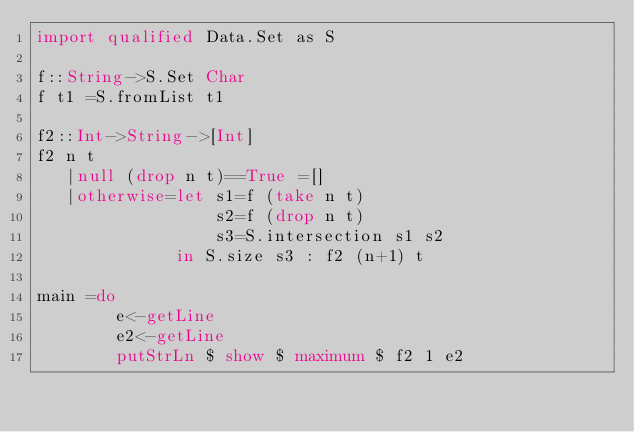<code> <loc_0><loc_0><loc_500><loc_500><_Haskell_>import qualified Data.Set as S

f::String->S.Set Char
f t1 =S.fromList t1

f2::Int->String->[Int]
f2 n t
   |null (drop n t)==True =[]
   |otherwise=let s1=f (take n t)
                  s2=f (drop n t)
                  s3=S.intersection s1 s2
              in S.size s3 : f2 (n+1) t

main =do
        e<-getLine
        e2<-getLine
        putStrLn $ show $ maximum $ f2 1 e2</code> 